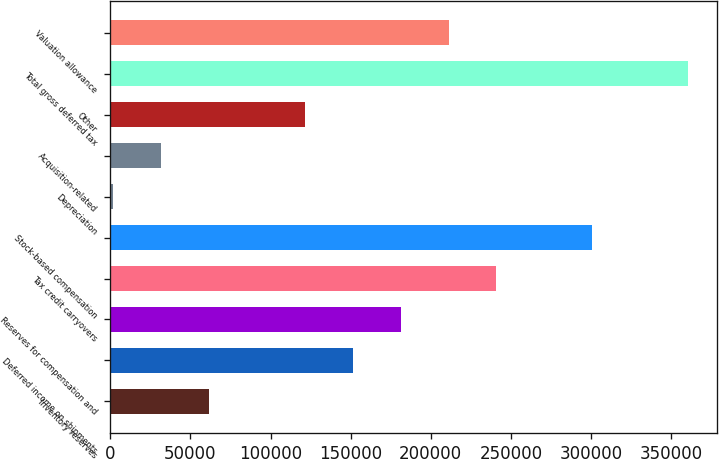<chart> <loc_0><loc_0><loc_500><loc_500><bar_chart><fcel>Inventory reserves<fcel>Deferred income on shipments<fcel>Reserves for compensation and<fcel>Tax credit carryovers<fcel>Stock-based compensation<fcel>Depreciation<fcel>Acquisition-related<fcel>Other<fcel>Total gross deferred tax<fcel>Valuation allowance<nl><fcel>61630.4<fcel>151316<fcel>181211<fcel>241002<fcel>300792<fcel>1840<fcel>31735.2<fcel>121421<fcel>360582<fcel>211106<nl></chart> 